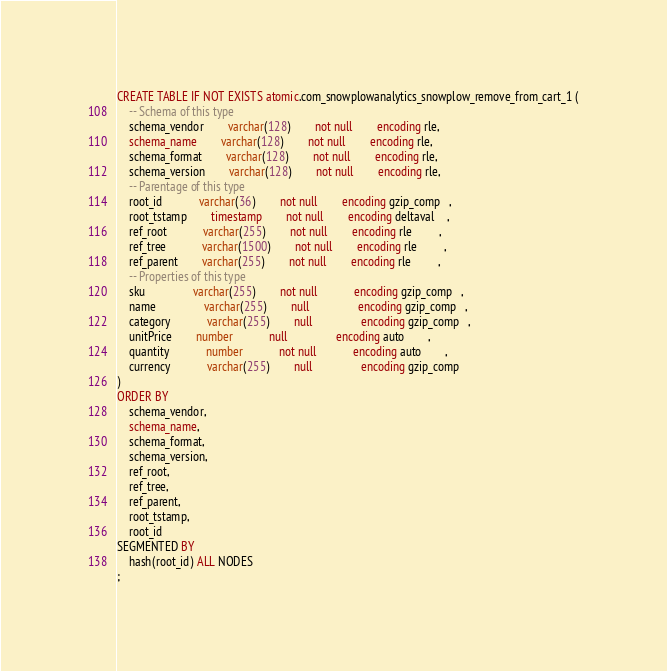<code> <loc_0><loc_0><loc_500><loc_500><_SQL_>CREATE TABLE IF NOT EXISTS atomic.com_snowplowanalytics_snowplow_remove_from_cart_1 (
	-- Schema of this type
	schema_vendor		varchar(128)		not null		encoding rle,
	schema_name 		varchar(128)		not null		encoding rle,
	schema_format		varchar(128)		not null		encoding rle,
	schema_version		varchar(128)		not null		encoding rle,
	-- Parentage of this type
	root_id     		varchar(36) 		not null		encoding gzip_comp   ,
	root_tstamp 		timestamp   		not null		encoding deltaval    ,
	ref_root    		varchar(255)		not null		encoding rle         ,
	ref_tree    		varchar(1500)		not null		encoding rle         ,
	ref_parent  		varchar(255)		not null		encoding rle         ,
	-- Properties of this type
	sku         		varchar(255)		not null    		encoding gzip_comp   ,
	name        		varchar(255)		null        		encoding gzip_comp   ,
	category    		varchar(255)		null        		encoding gzip_comp   ,
	unitPrice   		number      		null        		encoding auto        ,
	quantity    		number      		not null    		encoding auto        ,
	currency    		varchar(255)		null        		encoding gzip_comp   
)
ORDER BY
	schema_vendor,
	schema_name,
	schema_format,
	schema_version,
	ref_root,
	ref_tree,
	ref_parent,
	root_tstamp,
	root_id
SEGMENTED BY
	hash(root_id) ALL NODES
;</code> 